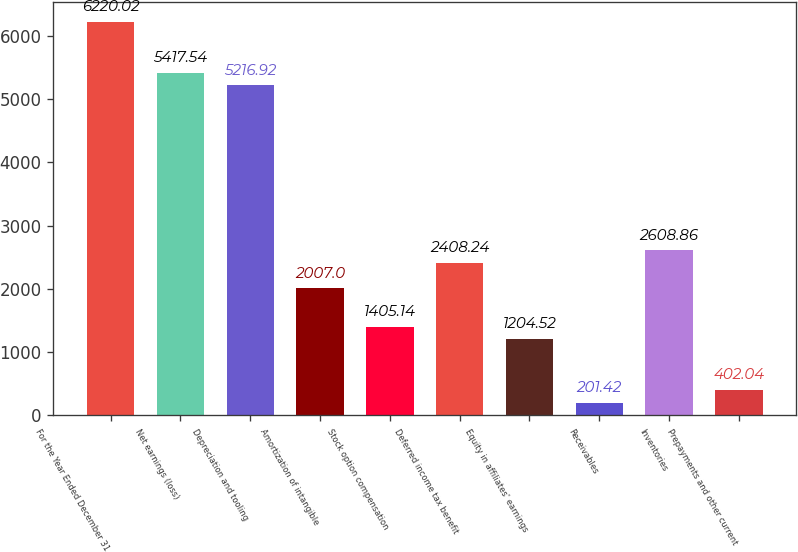Convert chart. <chart><loc_0><loc_0><loc_500><loc_500><bar_chart><fcel>For the Year Ended December 31<fcel>Net earnings (loss)<fcel>Depreciation and tooling<fcel>Amortization of intangible<fcel>Stock option compensation<fcel>Deferred income tax benefit<fcel>Equity in affiliates' earnings<fcel>Receivables<fcel>Inventories<fcel>Prepayments and other current<nl><fcel>6220.02<fcel>5417.54<fcel>5216.92<fcel>2007<fcel>1405.14<fcel>2408.24<fcel>1204.52<fcel>201.42<fcel>2608.86<fcel>402.04<nl></chart> 